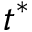<formula> <loc_0><loc_0><loc_500><loc_500>t ^ { * }</formula> 